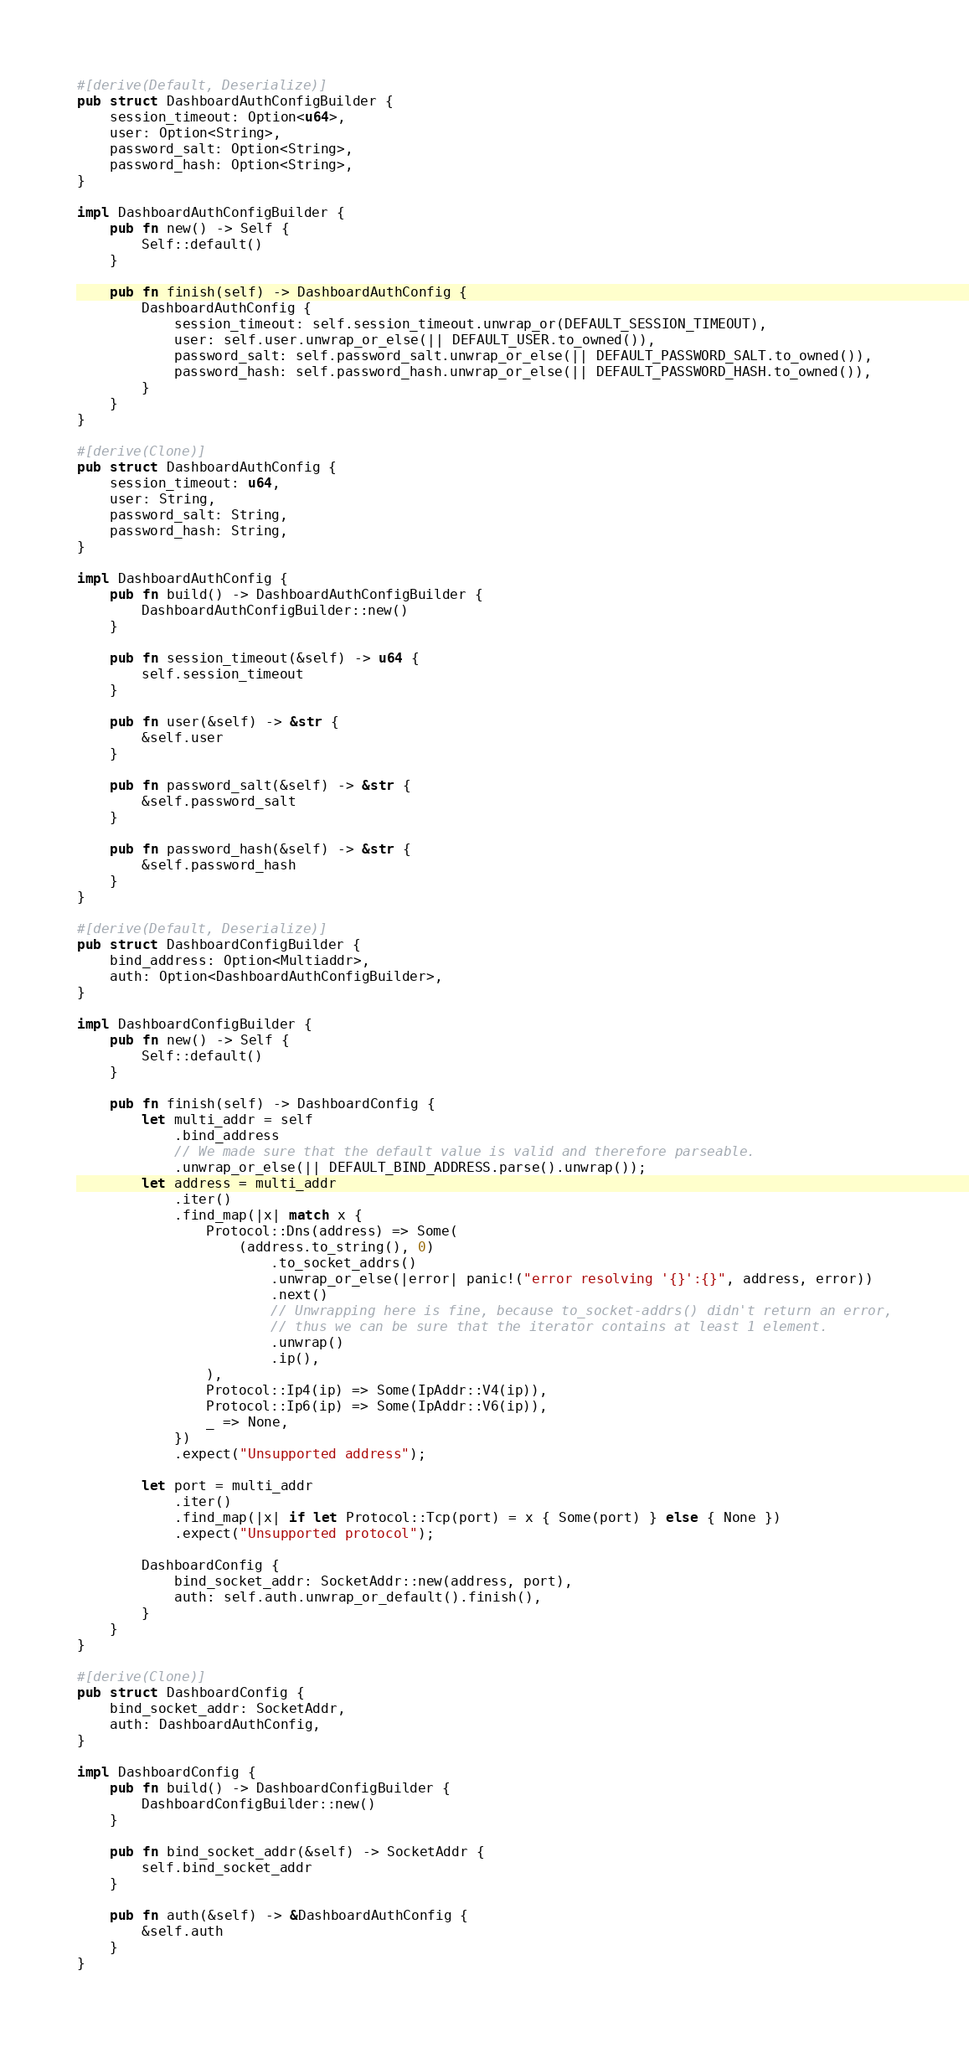<code> <loc_0><loc_0><loc_500><loc_500><_Rust_>
#[derive(Default, Deserialize)]
pub struct DashboardAuthConfigBuilder {
    session_timeout: Option<u64>,
    user: Option<String>,
    password_salt: Option<String>,
    password_hash: Option<String>,
}

impl DashboardAuthConfigBuilder {
    pub fn new() -> Self {
        Self::default()
    }

    pub fn finish(self) -> DashboardAuthConfig {
        DashboardAuthConfig {
            session_timeout: self.session_timeout.unwrap_or(DEFAULT_SESSION_TIMEOUT),
            user: self.user.unwrap_or_else(|| DEFAULT_USER.to_owned()),
            password_salt: self.password_salt.unwrap_or_else(|| DEFAULT_PASSWORD_SALT.to_owned()),
            password_hash: self.password_hash.unwrap_or_else(|| DEFAULT_PASSWORD_HASH.to_owned()),
        }
    }
}

#[derive(Clone)]
pub struct DashboardAuthConfig {
    session_timeout: u64,
    user: String,
    password_salt: String,
    password_hash: String,
}

impl DashboardAuthConfig {
    pub fn build() -> DashboardAuthConfigBuilder {
        DashboardAuthConfigBuilder::new()
    }

    pub fn session_timeout(&self) -> u64 {
        self.session_timeout
    }

    pub fn user(&self) -> &str {
        &self.user
    }

    pub fn password_salt(&self) -> &str {
        &self.password_salt
    }

    pub fn password_hash(&self) -> &str {
        &self.password_hash
    }
}

#[derive(Default, Deserialize)]
pub struct DashboardConfigBuilder {
    bind_address: Option<Multiaddr>,
    auth: Option<DashboardAuthConfigBuilder>,
}

impl DashboardConfigBuilder {
    pub fn new() -> Self {
        Self::default()
    }

    pub fn finish(self) -> DashboardConfig {
        let multi_addr = self
            .bind_address
            // We made sure that the default value is valid and therefore parseable.
            .unwrap_or_else(|| DEFAULT_BIND_ADDRESS.parse().unwrap());
        let address = multi_addr
            .iter()
            .find_map(|x| match x {
                Protocol::Dns(address) => Some(
                    (address.to_string(), 0)
                        .to_socket_addrs()
                        .unwrap_or_else(|error| panic!("error resolving '{}':{}", address, error))
                        .next()
                        // Unwrapping here is fine, because to_socket-addrs() didn't return an error,
                        // thus we can be sure that the iterator contains at least 1 element.
                        .unwrap()
                        .ip(),
                ),
                Protocol::Ip4(ip) => Some(IpAddr::V4(ip)),
                Protocol::Ip6(ip) => Some(IpAddr::V6(ip)),
                _ => None,
            })
            .expect("Unsupported address");

        let port = multi_addr
            .iter()
            .find_map(|x| if let Protocol::Tcp(port) = x { Some(port) } else { None })
            .expect("Unsupported protocol");

        DashboardConfig {
            bind_socket_addr: SocketAddr::new(address, port),
            auth: self.auth.unwrap_or_default().finish(),
        }
    }
}

#[derive(Clone)]
pub struct DashboardConfig {
    bind_socket_addr: SocketAddr,
    auth: DashboardAuthConfig,
}

impl DashboardConfig {
    pub fn build() -> DashboardConfigBuilder {
        DashboardConfigBuilder::new()
    }

    pub fn bind_socket_addr(&self) -> SocketAddr {
        self.bind_socket_addr
    }

    pub fn auth(&self) -> &DashboardAuthConfig {
        &self.auth
    }
}
</code> 